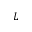<formula> <loc_0><loc_0><loc_500><loc_500>L</formula> 